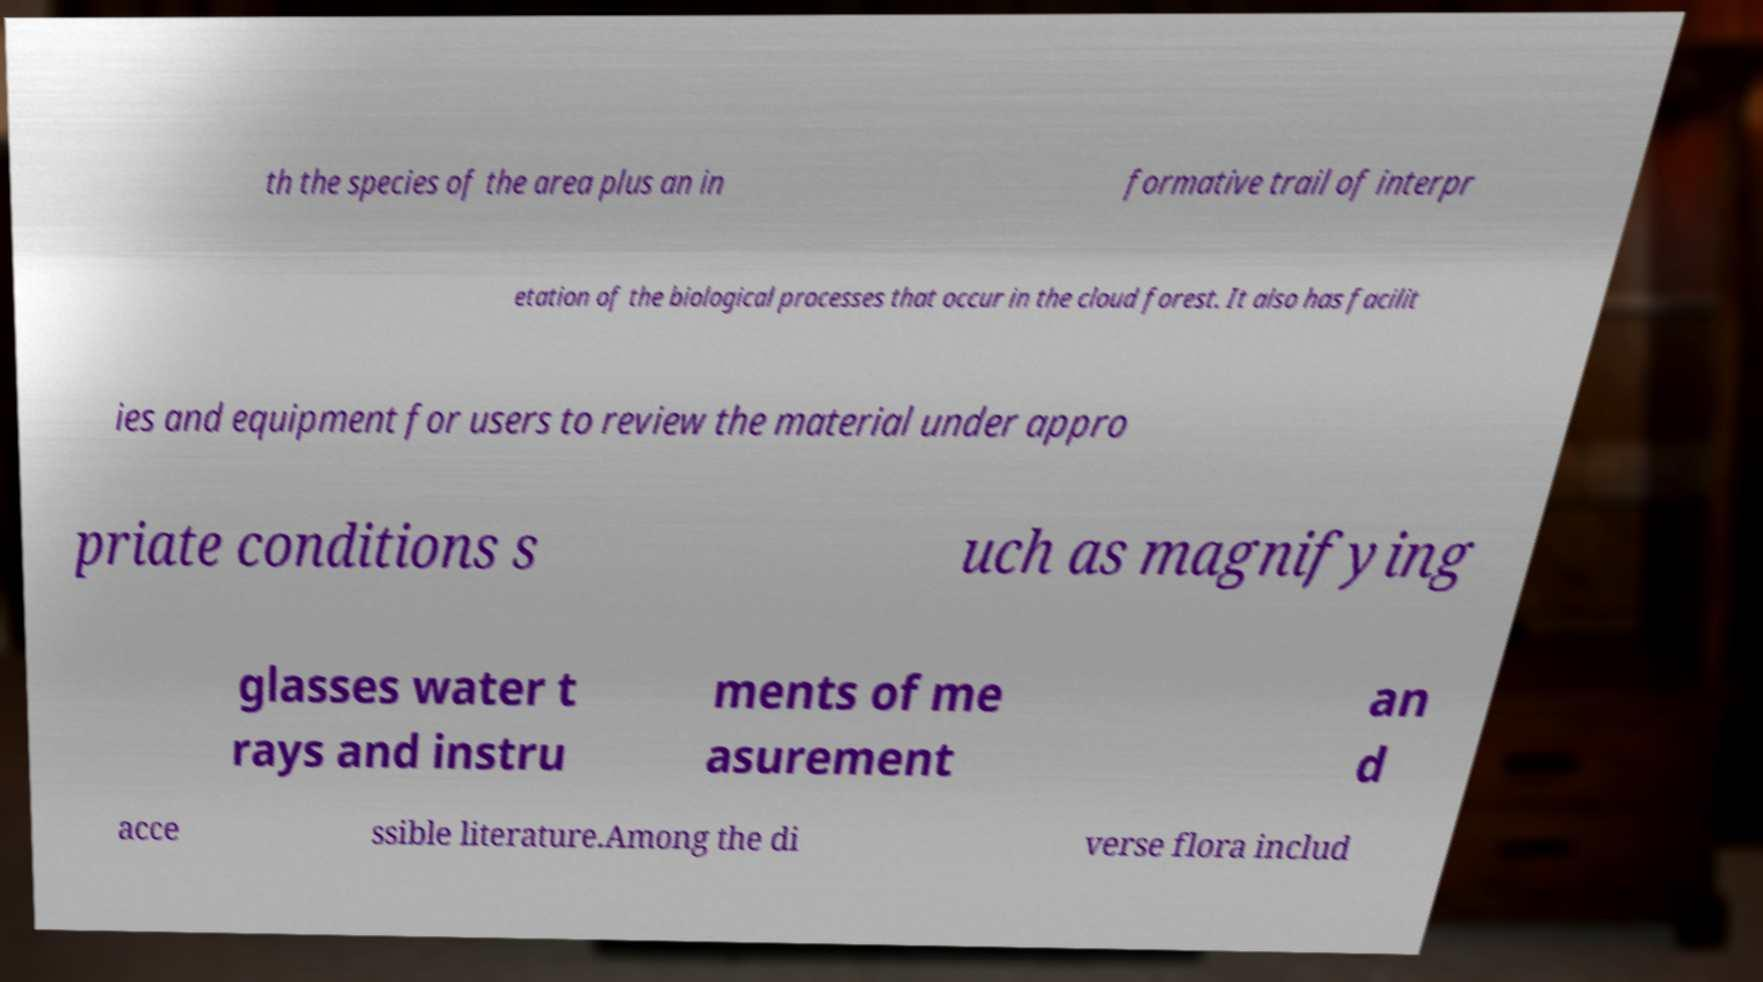Please read and relay the text visible in this image. What does it say? th the species of the area plus an in formative trail of interpr etation of the biological processes that occur in the cloud forest. It also has facilit ies and equipment for users to review the material under appro priate conditions s uch as magnifying glasses water t rays and instru ments of me asurement an d acce ssible literature.Among the di verse flora includ 